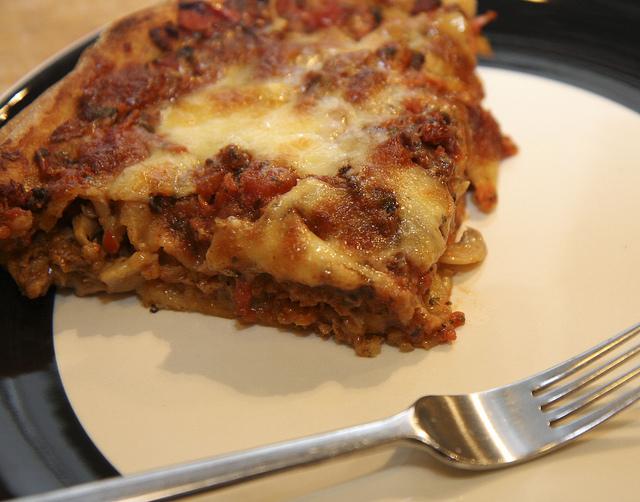Is this a Lasagna?
Write a very short answer. Yes. What food is on the plate?
Write a very short answer. Lasagna. What color is the fork?
Short answer required. Silver. 